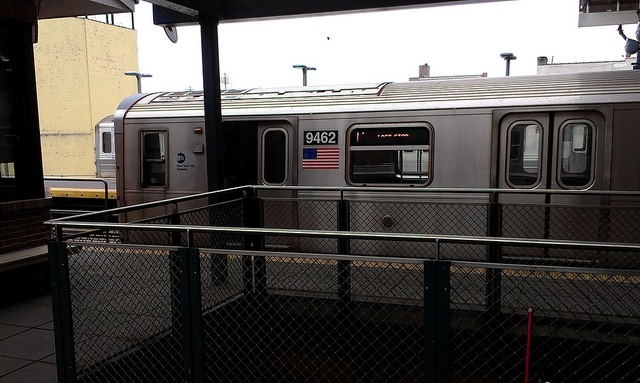Describe the objects in this image and their specific colors. I can see train in black, gray, lightgray, and darkgray tones and bench in black and gray tones in this image. 